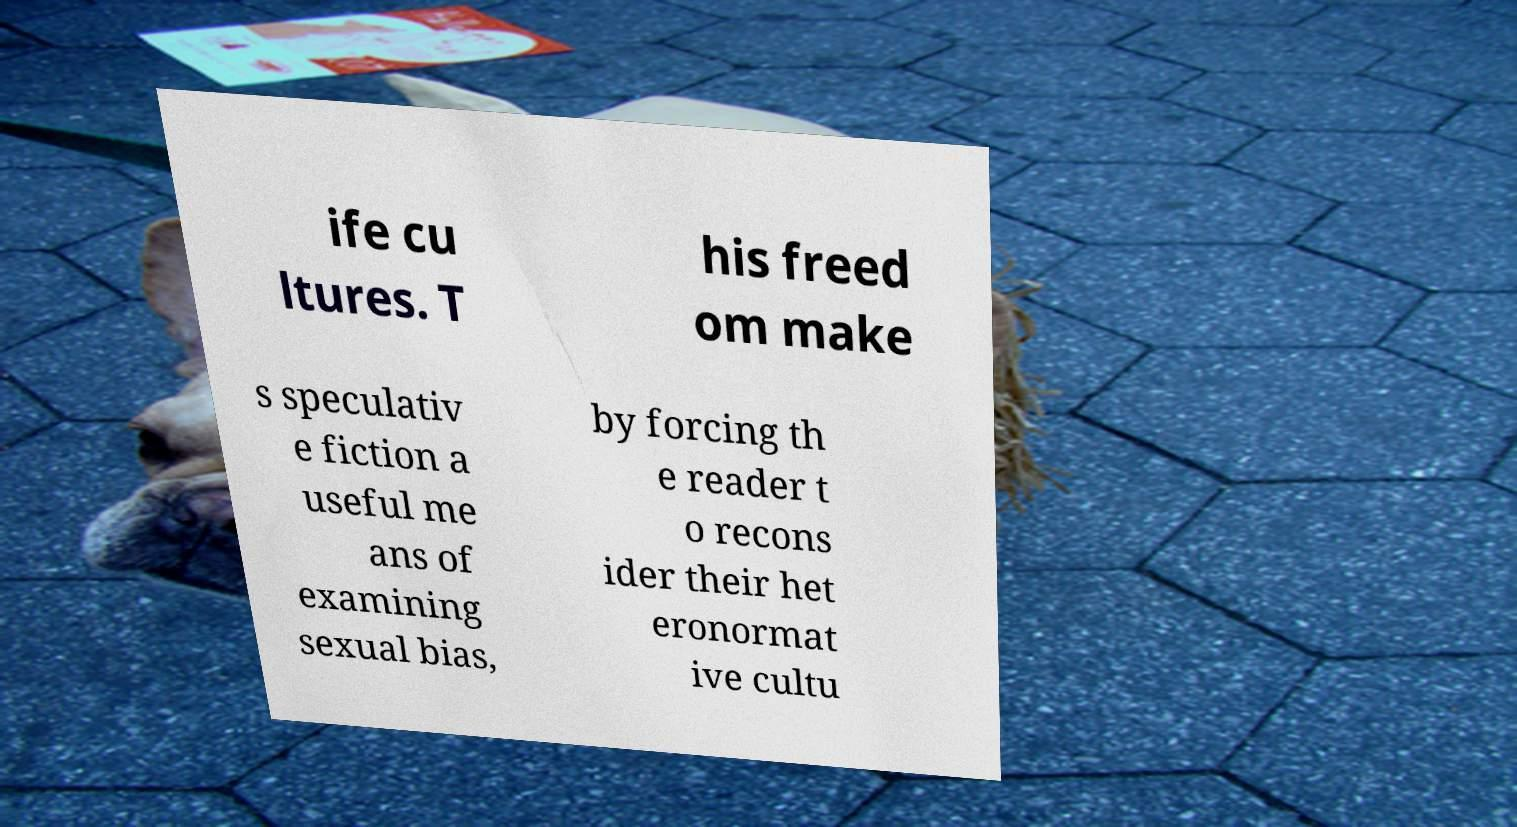Could you extract and type out the text from this image? ife cu ltures. T his freed om make s speculativ e fiction a useful me ans of examining sexual bias, by forcing th e reader t o recons ider their het eronormat ive cultu 